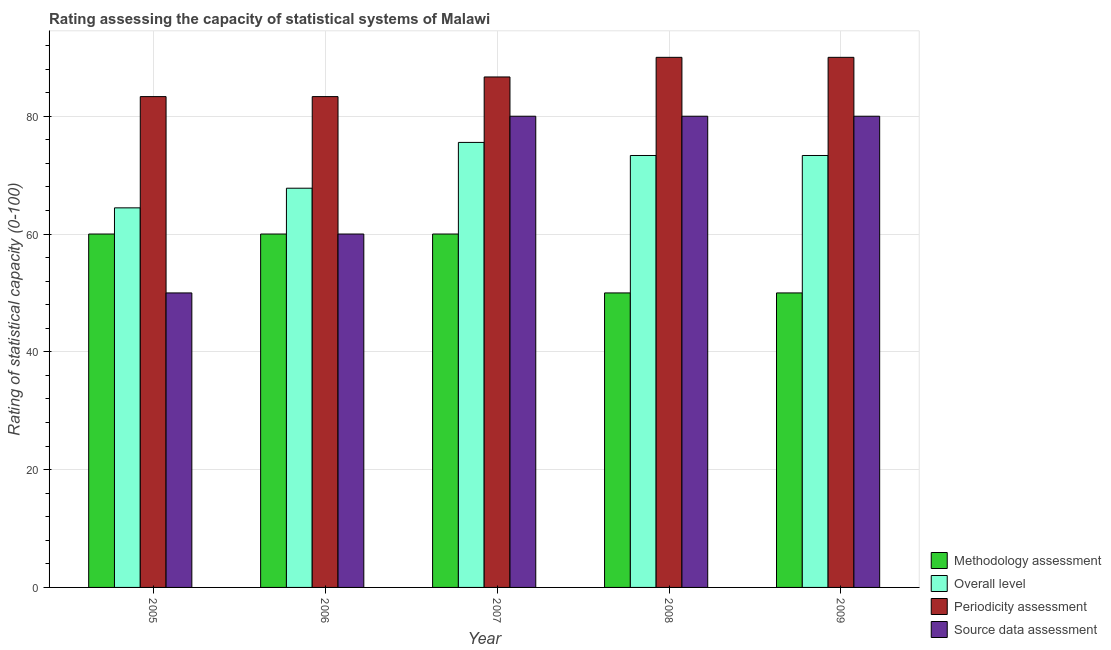Are the number of bars per tick equal to the number of legend labels?
Ensure brevity in your answer.  Yes. Are the number of bars on each tick of the X-axis equal?
Your answer should be compact. Yes. In how many cases, is the number of bars for a given year not equal to the number of legend labels?
Your answer should be very brief. 0. What is the periodicity assessment rating in 2006?
Ensure brevity in your answer.  83.33. Across all years, what is the maximum methodology assessment rating?
Give a very brief answer. 60. Across all years, what is the minimum overall level rating?
Offer a terse response. 64.44. In which year was the methodology assessment rating minimum?
Offer a terse response. 2008. What is the total periodicity assessment rating in the graph?
Offer a terse response. 433.33. What is the difference between the methodology assessment rating in 2006 and that in 2007?
Offer a terse response. 0. What is the difference between the overall level rating in 2005 and the periodicity assessment rating in 2007?
Give a very brief answer. -11.11. What is the average periodicity assessment rating per year?
Ensure brevity in your answer.  86.67. What is the ratio of the methodology assessment rating in 2007 to that in 2009?
Ensure brevity in your answer.  1.2. What is the difference between the highest and the second highest source data assessment rating?
Your answer should be very brief. 0. What is the difference between the highest and the lowest source data assessment rating?
Your response must be concise. 30. Is the sum of the methodology assessment rating in 2006 and 2007 greater than the maximum overall level rating across all years?
Make the answer very short. Yes. What does the 2nd bar from the left in 2005 represents?
Your response must be concise. Overall level. What does the 3rd bar from the right in 2008 represents?
Offer a very short reply. Overall level. Is it the case that in every year, the sum of the methodology assessment rating and overall level rating is greater than the periodicity assessment rating?
Your answer should be very brief. Yes. How many bars are there?
Provide a succinct answer. 20. Are all the bars in the graph horizontal?
Make the answer very short. No. How many years are there in the graph?
Make the answer very short. 5. What is the difference between two consecutive major ticks on the Y-axis?
Provide a short and direct response. 20. Are the values on the major ticks of Y-axis written in scientific E-notation?
Make the answer very short. No. Does the graph contain any zero values?
Your response must be concise. No. Does the graph contain grids?
Make the answer very short. Yes. Where does the legend appear in the graph?
Offer a very short reply. Bottom right. How many legend labels are there?
Keep it short and to the point. 4. What is the title of the graph?
Keep it short and to the point. Rating assessing the capacity of statistical systems of Malawi. Does "Secondary general education" appear as one of the legend labels in the graph?
Your response must be concise. No. What is the label or title of the X-axis?
Offer a very short reply. Year. What is the label or title of the Y-axis?
Your answer should be compact. Rating of statistical capacity (0-100). What is the Rating of statistical capacity (0-100) in Overall level in 2005?
Make the answer very short. 64.44. What is the Rating of statistical capacity (0-100) in Periodicity assessment in 2005?
Keep it short and to the point. 83.33. What is the Rating of statistical capacity (0-100) of Source data assessment in 2005?
Ensure brevity in your answer.  50. What is the Rating of statistical capacity (0-100) of Methodology assessment in 2006?
Your response must be concise. 60. What is the Rating of statistical capacity (0-100) of Overall level in 2006?
Provide a short and direct response. 67.78. What is the Rating of statistical capacity (0-100) in Periodicity assessment in 2006?
Your answer should be compact. 83.33. What is the Rating of statistical capacity (0-100) of Source data assessment in 2006?
Keep it short and to the point. 60. What is the Rating of statistical capacity (0-100) of Methodology assessment in 2007?
Ensure brevity in your answer.  60. What is the Rating of statistical capacity (0-100) of Overall level in 2007?
Offer a terse response. 75.56. What is the Rating of statistical capacity (0-100) in Periodicity assessment in 2007?
Your response must be concise. 86.67. What is the Rating of statistical capacity (0-100) in Methodology assessment in 2008?
Provide a succinct answer. 50. What is the Rating of statistical capacity (0-100) in Overall level in 2008?
Your answer should be very brief. 73.33. What is the Rating of statistical capacity (0-100) of Periodicity assessment in 2008?
Offer a very short reply. 90. What is the Rating of statistical capacity (0-100) in Source data assessment in 2008?
Your response must be concise. 80. What is the Rating of statistical capacity (0-100) of Overall level in 2009?
Make the answer very short. 73.33. What is the Rating of statistical capacity (0-100) of Periodicity assessment in 2009?
Give a very brief answer. 90. What is the Rating of statistical capacity (0-100) of Source data assessment in 2009?
Provide a short and direct response. 80. Across all years, what is the maximum Rating of statistical capacity (0-100) of Methodology assessment?
Your response must be concise. 60. Across all years, what is the maximum Rating of statistical capacity (0-100) in Overall level?
Offer a terse response. 75.56. Across all years, what is the minimum Rating of statistical capacity (0-100) in Methodology assessment?
Offer a terse response. 50. Across all years, what is the minimum Rating of statistical capacity (0-100) in Overall level?
Your response must be concise. 64.44. Across all years, what is the minimum Rating of statistical capacity (0-100) in Periodicity assessment?
Your answer should be compact. 83.33. What is the total Rating of statistical capacity (0-100) of Methodology assessment in the graph?
Provide a short and direct response. 280. What is the total Rating of statistical capacity (0-100) in Overall level in the graph?
Your answer should be compact. 354.44. What is the total Rating of statistical capacity (0-100) of Periodicity assessment in the graph?
Ensure brevity in your answer.  433.33. What is the total Rating of statistical capacity (0-100) of Source data assessment in the graph?
Give a very brief answer. 350. What is the difference between the Rating of statistical capacity (0-100) in Methodology assessment in 2005 and that in 2006?
Provide a short and direct response. 0. What is the difference between the Rating of statistical capacity (0-100) in Periodicity assessment in 2005 and that in 2006?
Give a very brief answer. 0. What is the difference between the Rating of statistical capacity (0-100) of Overall level in 2005 and that in 2007?
Offer a very short reply. -11.11. What is the difference between the Rating of statistical capacity (0-100) in Source data assessment in 2005 and that in 2007?
Your response must be concise. -30. What is the difference between the Rating of statistical capacity (0-100) of Methodology assessment in 2005 and that in 2008?
Give a very brief answer. 10. What is the difference between the Rating of statistical capacity (0-100) of Overall level in 2005 and that in 2008?
Make the answer very short. -8.89. What is the difference between the Rating of statistical capacity (0-100) in Periodicity assessment in 2005 and that in 2008?
Provide a short and direct response. -6.67. What is the difference between the Rating of statistical capacity (0-100) in Source data assessment in 2005 and that in 2008?
Give a very brief answer. -30. What is the difference between the Rating of statistical capacity (0-100) of Overall level in 2005 and that in 2009?
Offer a very short reply. -8.89. What is the difference between the Rating of statistical capacity (0-100) in Periodicity assessment in 2005 and that in 2009?
Offer a very short reply. -6.67. What is the difference between the Rating of statistical capacity (0-100) of Methodology assessment in 2006 and that in 2007?
Keep it short and to the point. 0. What is the difference between the Rating of statistical capacity (0-100) of Overall level in 2006 and that in 2007?
Keep it short and to the point. -7.78. What is the difference between the Rating of statistical capacity (0-100) in Source data assessment in 2006 and that in 2007?
Give a very brief answer. -20. What is the difference between the Rating of statistical capacity (0-100) of Methodology assessment in 2006 and that in 2008?
Provide a succinct answer. 10. What is the difference between the Rating of statistical capacity (0-100) in Overall level in 2006 and that in 2008?
Your answer should be compact. -5.56. What is the difference between the Rating of statistical capacity (0-100) of Periodicity assessment in 2006 and that in 2008?
Provide a short and direct response. -6.67. What is the difference between the Rating of statistical capacity (0-100) in Overall level in 2006 and that in 2009?
Make the answer very short. -5.56. What is the difference between the Rating of statistical capacity (0-100) of Periodicity assessment in 2006 and that in 2009?
Your answer should be very brief. -6.67. What is the difference between the Rating of statistical capacity (0-100) in Source data assessment in 2006 and that in 2009?
Offer a terse response. -20. What is the difference between the Rating of statistical capacity (0-100) of Overall level in 2007 and that in 2008?
Keep it short and to the point. 2.22. What is the difference between the Rating of statistical capacity (0-100) of Source data assessment in 2007 and that in 2008?
Offer a very short reply. 0. What is the difference between the Rating of statistical capacity (0-100) of Overall level in 2007 and that in 2009?
Your answer should be very brief. 2.22. What is the difference between the Rating of statistical capacity (0-100) of Periodicity assessment in 2007 and that in 2009?
Make the answer very short. -3.33. What is the difference between the Rating of statistical capacity (0-100) in Source data assessment in 2007 and that in 2009?
Ensure brevity in your answer.  0. What is the difference between the Rating of statistical capacity (0-100) in Periodicity assessment in 2008 and that in 2009?
Your answer should be compact. 0. What is the difference between the Rating of statistical capacity (0-100) of Source data assessment in 2008 and that in 2009?
Make the answer very short. 0. What is the difference between the Rating of statistical capacity (0-100) in Methodology assessment in 2005 and the Rating of statistical capacity (0-100) in Overall level in 2006?
Keep it short and to the point. -7.78. What is the difference between the Rating of statistical capacity (0-100) in Methodology assessment in 2005 and the Rating of statistical capacity (0-100) in Periodicity assessment in 2006?
Your response must be concise. -23.33. What is the difference between the Rating of statistical capacity (0-100) in Overall level in 2005 and the Rating of statistical capacity (0-100) in Periodicity assessment in 2006?
Your response must be concise. -18.89. What is the difference between the Rating of statistical capacity (0-100) in Overall level in 2005 and the Rating of statistical capacity (0-100) in Source data assessment in 2006?
Offer a very short reply. 4.44. What is the difference between the Rating of statistical capacity (0-100) in Periodicity assessment in 2005 and the Rating of statistical capacity (0-100) in Source data assessment in 2006?
Ensure brevity in your answer.  23.33. What is the difference between the Rating of statistical capacity (0-100) of Methodology assessment in 2005 and the Rating of statistical capacity (0-100) of Overall level in 2007?
Offer a very short reply. -15.56. What is the difference between the Rating of statistical capacity (0-100) of Methodology assessment in 2005 and the Rating of statistical capacity (0-100) of Periodicity assessment in 2007?
Provide a succinct answer. -26.67. What is the difference between the Rating of statistical capacity (0-100) of Overall level in 2005 and the Rating of statistical capacity (0-100) of Periodicity assessment in 2007?
Keep it short and to the point. -22.22. What is the difference between the Rating of statistical capacity (0-100) of Overall level in 2005 and the Rating of statistical capacity (0-100) of Source data assessment in 2007?
Your response must be concise. -15.56. What is the difference between the Rating of statistical capacity (0-100) of Periodicity assessment in 2005 and the Rating of statistical capacity (0-100) of Source data assessment in 2007?
Make the answer very short. 3.33. What is the difference between the Rating of statistical capacity (0-100) in Methodology assessment in 2005 and the Rating of statistical capacity (0-100) in Overall level in 2008?
Ensure brevity in your answer.  -13.33. What is the difference between the Rating of statistical capacity (0-100) of Methodology assessment in 2005 and the Rating of statistical capacity (0-100) of Periodicity assessment in 2008?
Offer a very short reply. -30. What is the difference between the Rating of statistical capacity (0-100) of Overall level in 2005 and the Rating of statistical capacity (0-100) of Periodicity assessment in 2008?
Provide a short and direct response. -25.56. What is the difference between the Rating of statistical capacity (0-100) of Overall level in 2005 and the Rating of statistical capacity (0-100) of Source data assessment in 2008?
Give a very brief answer. -15.56. What is the difference between the Rating of statistical capacity (0-100) of Methodology assessment in 2005 and the Rating of statistical capacity (0-100) of Overall level in 2009?
Offer a very short reply. -13.33. What is the difference between the Rating of statistical capacity (0-100) of Methodology assessment in 2005 and the Rating of statistical capacity (0-100) of Periodicity assessment in 2009?
Ensure brevity in your answer.  -30. What is the difference between the Rating of statistical capacity (0-100) in Overall level in 2005 and the Rating of statistical capacity (0-100) in Periodicity assessment in 2009?
Your answer should be very brief. -25.56. What is the difference between the Rating of statistical capacity (0-100) in Overall level in 2005 and the Rating of statistical capacity (0-100) in Source data assessment in 2009?
Make the answer very short. -15.56. What is the difference between the Rating of statistical capacity (0-100) in Methodology assessment in 2006 and the Rating of statistical capacity (0-100) in Overall level in 2007?
Give a very brief answer. -15.56. What is the difference between the Rating of statistical capacity (0-100) in Methodology assessment in 2006 and the Rating of statistical capacity (0-100) in Periodicity assessment in 2007?
Ensure brevity in your answer.  -26.67. What is the difference between the Rating of statistical capacity (0-100) of Overall level in 2006 and the Rating of statistical capacity (0-100) of Periodicity assessment in 2007?
Your answer should be compact. -18.89. What is the difference between the Rating of statistical capacity (0-100) in Overall level in 2006 and the Rating of statistical capacity (0-100) in Source data assessment in 2007?
Provide a short and direct response. -12.22. What is the difference between the Rating of statistical capacity (0-100) in Periodicity assessment in 2006 and the Rating of statistical capacity (0-100) in Source data assessment in 2007?
Keep it short and to the point. 3.33. What is the difference between the Rating of statistical capacity (0-100) in Methodology assessment in 2006 and the Rating of statistical capacity (0-100) in Overall level in 2008?
Ensure brevity in your answer.  -13.33. What is the difference between the Rating of statistical capacity (0-100) of Methodology assessment in 2006 and the Rating of statistical capacity (0-100) of Periodicity assessment in 2008?
Keep it short and to the point. -30. What is the difference between the Rating of statistical capacity (0-100) in Overall level in 2006 and the Rating of statistical capacity (0-100) in Periodicity assessment in 2008?
Make the answer very short. -22.22. What is the difference between the Rating of statistical capacity (0-100) of Overall level in 2006 and the Rating of statistical capacity (0-100) of Source data assessment in 2008?
Provide a succinct answer. -12.22. What is the difference between the Rating of statistical capacity (0-100) of Periodicity assessment in 2006 and the Rating of statistical capacity (0-100) of Source data assessment in 2008?
Provide a succinct answer. 3.33. What is the difference between the Rating of statistical capacity (0-100) of Methodology assessment in 2006 and the Rating of statistical capacity (0-100) of Overall level in 2009?
Provide a short and direct response. -13.33. What is the difference between the Rating of statistical capacity (0-100) of Overall level in 2006 and the Rating of statistical capacity (0-100) of Periodicity assessment in 2009?
Your answer should be compact. -22.22. What is the difference between the Rating of statistical capacity (0-100) in Overall level in 2006 and the Rating of statistical capacity (0-100) in Source data assessment in 2009?
Your response must be concise. -12.22. What is the difference between the Rating of statistical capacity (0-100) of Methodology assessment in 2007 and the Rating of statistical capacity (0-100) of Overall level in 2008?
Your answer should be very brief. -13.33. What is the difference between the Rating of statistical capacity (0-100) of Methodology assessment in 2007 and the Rating of statistical capacity (0-100) of Source data assessment in 2008?
Offer a terse response. -20. What is the difference between the Rating of statistical capacity (0-100) of Overall level in 2007 and the Rating of statistical capacity (0-100) of Periodicity assessment in 2008?
Your answer should be very brief. -14.44. What is the difference between the Rating of statistical capacity (0-100) in Overall level in 2007 and the Rating of statistical capacity (0-100) in Source data assessment in 2008?
Provide a succinct answer. -4.44. What is the difference between the Rating of statistical capacity (0-100) in Methodology assessment in 2007 and the Rating of statistical capacity (0-100) in Overall level in 2009?
Ensure brevity in your answer.  -13.33. What is the difference between the Rating of statistical capacity (0-100) of Methodology assessment in 2007 and the Rating of statistical capacity (0-100) of Source data assessment in 2009?
Provide a short and direct response. -20. What is the difference between the Rating of statistical capacity (0-100) of Overall level in 2007 and the Rating of statistical capacity (0-100) of Periodicity assessment in 2009?
Ensure brevity in your answer.  -14.44. What is the difference between the Rating of statistical capacity (0-100) in Overall level in 2007 and the Rating of statistical capacity (0-100) in Source data assessment in 2009?
Give a very brief answer. -4.44. What is the difference between the Rating of statistical capacity (0-100) of Periodicity assessment in 2007 and the Rating of statistical capacity (0-100) of Source data assessment in 2009?
Keep it short and to the point. 6.67. What is the difference between the Rating of statistical capacity (0-100) of Methodology assessment in 2008 and the Rating of statistical capacity (0-100) of Overall level in 2009?
Ensure brevity in your answer.  -23.33. What is the difference between the Rating of statistical capacity (0-100) in Methodology assessment in 2008 and the Rating of statistical capacity (0-100) in Periodicity assessment in 2009?
Your answer should be very brief. -40. What is the difference between the Rating of statistical capacity (0-100) in Overall level in 2008 and the Rating of statistical capacity (0-100) in Periodicity assessment in 2009?
Offer a terse response. -16.67. What is the difference between the Rating of statistical capacity (0-100) of Overall level in 2008 and the Rating of statistical capacity (0-100) of Source data assessment in 2009?
Keep it short and to the point. -6.67. What is the difference between the Rating of statistical capacity (0-100) of Periodicity assessment in 2008 and the Rating of statistical capacity (0-100) of Source data assessment in 2009?
Your answer should be very brief. 10. What is the average Rating of statistical capacity (0-100) of Overall level per year?
Ensure brevity in your answer.  70.89. What is the average Rating of statistical capacity (0-100) of Periodicity assessment per year?
Offer a terse response. 86.67. In the year 2005, what is the difference between the Rating of statistical capacity (0-100) in Methodology assessment and Rating of statistical capacity (0-100) in Overall level?
Offer a very short reply. -4.44. In the year 2005, what is the difference between the Rating of statistical capacity (0-100) in Methodology assessment and Rating of statistical capacity (0-100) in Periodicity assessment?
Offer a very short reply. -23.33. In the year 2005, what is the difference between the Rating of statistical capacity (0-100) of Overall level and Rating of statistical capacity (0-100) of Periodicity assessment?
Your answer should be very brief. -18.89. In the year 2005, what is the difference between the Rating of statistical capacity (0-100) in Overall level and Rating of statistical capacity (0-100) in Source data assessment?
Your answer should be compact. 14.44. In the year 2005, what is the difference between the Rating of statistical capacity (0-100) of Periodicity assessment and Rating of statistical capacity (0-100) of Source data assessment?
Provide a succinct answer. 33.33. In the year 2006, what is the difference between the Rating of statistical capacity (0-100) of Methodology assessment and Rating of statistical capacity (0-100) of Overall level?
Provide a short and direct response. -7.78. In the year 2006, what is the difference between the Rating of statistical capacity (0-100) of Methodology assessment and Rating of statistical capacity (0-100) of Periodicity assessment?
Make the answer very short. -23.33. In the year 2006, what is the difference between the Rating of statistical capacity (0-100) of Overall level and Rating of statistical capacity (0-100) of Periodicity assessment?
Make the answer very short. -15.56. In the year 2006, what is the difference between the Rating of statistical capacity (0-100) in Overall level and Rating of statistical capacity (0-100) in Source data assessment?
Ensure brevity in your answer.  7.78. In the year 2006, what is the difference between the Rating of statistical capacity (0-100) in Periodicity assessment and Rating of statistical capacity (0-100) in Source data assessment?
Your answer should be very brief. 23.33. In the year 2007, what is the difference between the Rating of statistical capacity (0-100) of Methodology assessment and Rating of statistical capacity (0-100) of Overall level?
Your response must be concise. -15.56. In the year 2007, what is the difference between the Rating of statistical capacity (0-100) of Methodology assessment and Rating of statistical capacity (0-100) of Periodicity assessment?
Ensure brevity in your answer.  -26.67. In the year 2007, what is the difference between the Rating of statistical capacity (0-100) of Methodology assessment and Rating of statistical capacity (0-100) of Source data assessment?
Your response must be concise. -20. In the year 2007, what is the difference between the Rating of statistical capacity (0-100) in Overall level and Rating of statistical capacity (0-100) in Periodicity assessment?
Offer a very short reply. -11.11. In the year 2007, what is the difference between the Rating of statistical capacity (0-100) in Overall level and Rating of statistical capacity (0-100) in Source data assessment?
Ensure brevity in your answer.  -4.44. In the year 2007, what is the difference between the Rating of statistical capacity (0-100) of Periodicity assessment and Rating of statistical capacity (0-100) of Source data assessment?
Ensure brevity in your answer.  6.67. In the year 2008, what is the difference between the Rating of statistical capacity (0-100) in Methodology assessment and Rating of statistical capacity (0-100) in Overall level?
Provide a short and direct response. -23.33. In the year 2008, what is the difference between the Rating of statistical capacity (0-100) in Methodology assessment and Rating of statistical capacity (0-100) in Source data assessment?
Make the answer very short. -30. In the year 2008, what is the difference between the Rating of statistical capacity (0-100) in Overall level and Rating of statistical capacity (0-100) in Periodicity assessment?
Ensure brevity in your answer.  -16.67. In the year 2008, what is the difference between the Rating of statistical capacity (0-100) in Overall level and Rating of statistical capacity (0-100) in Source data assessment?
Your response must be concise. -6.67. In the year 2008, what is the difference between the Rating of statistical capacity (0-100) in Periodicity assessment and Rating of statistical capacity (0-100) in Source data assessment?
Your answer should be compact. 10. In the year 2009, what is the difference between the Rating of statistical capacity (0-100) of Methodology assessment and Rating of statistical capacity (0-100) of Overall level?
Provide a succinct answer. -23.33. In the year 2009, what is the difference between the Rating of statistical capacity (0-100) of Methodology assessment and Rating of statistical capacity (0-100) of Periodicity assessment?
Make the answer very short. -40. In the year 2009, what is the difference between the Rating of statistical capacity (0-100) in Methodology assessment and Rating of statistical capacity (0-100) in Source data assessment?
Give a very brief answer. -30. In the year 2009, what is the difference between the Rating of statistical capacity (0-100) in Overall level and Rating of statistical capacity (0-100) in Periodicity assessment?
Give a very brief answer. -16.67. In the year 2009, what is the difference between the Rating of statistical capacity (0-100) in Overall level and Rating of statistical capacity (0-100) in Source data assessment?
Keep it short and to the point. -6.67. In the year 2009, what is the difference between the Rating of statistical capacity (0-100) of Periodicity assessment and Rating of statistical capacity (0-100) of Source data assessment?
Ensure brevity in your answer.  10. What is the ratio of the Rating of statistical capacity (0-100) of Methodology assessment in 2005 to that in 2006?
Offer a very short reply. 1. What is the ratio of the Rating of statistical capacity (0-100) of Overall level in 2005 to that in 2006?
Keep it short and to the point. 0.95. What is the ratio of the Rating of statistical capacity (0-100) of Source data assessment in 2005 to that in 2006?
Provide a short and direct response. 0.83. What is the ratio of the Rating of statistical capacity (0-100) in Methodology assessment in 2005 to that in 2007?
Provide a short and direct response. 1. What is the ratio of the Rating of statistical capacity (0-100) of Overall level in 2005 to that in 2007?
Offer a terse response. 0.85. What is the ratio of the Rating of statistical capacity (0-100) of Periodicity assessment in 2005 to that in 2007?
Give a very brief answer. 0.96. What is the ratio of the Rating of statistical capacity (0-100) of Methodology assessment in 2005 to that in 2008?
Ensure brevity in your answer.  1.2. What is the ratio of the Rating of statistical capacity (0-100) in Overall level in 2005 to that in 2008?
Provide a short and direct response. 0.88. What is the ratio of the Rating of statistical capacity (0-100) of Periodicity assessment in 2005 to that in 2008?
Your response must be concise. 0.93. What is the ratio of the Rating of statistical capacity (0-100) of Source data assessment in 2005 to that in 2008?
Your response must be concise. 0.62. What is the ratio of the Rating of statistical capacity (0-100) of Overall level in 2005 to that in 2009?
Give a very brief answer. 0.88. What is the ratio of the Rating of statistical capacity (0-100) of Periodicity assessment in 2005 to that in 2009?
Offer a very short reply. 0.93. What is the ratio of the Rating of statistical capacity (0-100) of Methodology assessment in 2006 to that in 2007?
Provide a short and direct response. 1. What is the ratio of the Rating of statistical capacity (0-100) of Overall level in 2006 to that in 2007?
Provide a succinct answer. 0.9. What is the ratio of the Rating of statistical capacity (0-100) in Periodicity assessment in 2006 to that in 2007?
Your response must be concise. 0.96. What is the ratio of the Rating of statistical capacity (0-100) in Source data assessment in 2006 to that in 2007?
Your response must be concise. 0.75. What is the ratio of the Rating of statistical capacity (0-100) in Methodology assessment in 2006 to that in 2008?
Offer a very short reply. 1.2. What is the ratio of the Rating of statistical capacity (0-100) in Overall level in 2006 to that in 2008?
Your answer should be compact. 0.92. What is the ratio of the Rating of statistical capacity (0-100) of Periodicity assessment in 2006 to that in 2008?
Your response must be concise. 0.93. What is the ratio of the Rating of statistical capacity (0-100) in Overall level in 2006 to that in 2009?
Offer a terse response. 0.92. What is the ratio of the Rating of statistical capacity (0-100) in Periodicity assessment in 2006 to that in 2009?
Make the answer very short. 0.93. What is the ratio of the Rating of statistical capacity (0-100) of Source data assessment in 2006 to that in 2009?
Your answer should be very brief. 0.75. What is the ratio of the Rating of statistical capacity (0-100) of Methodology assessment in 2007 to that in 2008?
Give a very brief answer. 1.2. What is the ratio of the Rating of statistical capacity (0-100) of Overall level in 2007 to that in 2008?
Offer a very short reply. 1.03. What is the ratio of the Rating of statistical capacity (0-100) of Overall level in 2007 to that in 2009?
Make the answer very short. 1.03. What is the ratio of the Rating of statistical capacity (0-100) in Overall level in 2008 to that in 2009?
Your response must be concise. 1. What is the difference between the highest and the second highest Rating of statistical capacity (0-100) of Methodology assessment?
Give a very brief answer. 0. What is the difference between the highest and the second highest Rating of statistical capacity (0-100) of Overall level?
Your response must be concise. 2.22. What is the difference between the highest and the second highest Rating of statistical capacity (0-100) in Periodicity assessment?
Provide a succinct answer. 0. What is the difference between the highest and the lowest Rating of statistical capacity (0-100) of Methodology assessment?
Provide a short and direct response. 10. What is the difference between the highest and the lowest Rating of statistical capacity (0-100) of Overall level?
Your answer should be compact. 11.11. What is the difference between the highest and the lowest Rating of statistical capacity (0-100) of Periodicity assessment?
Offer a very short reply. 6.67. What is the difference between the highest and the lowest Rating of statistical capacity (0-100) in Source data assessment?
Your response must be concise. 30. 